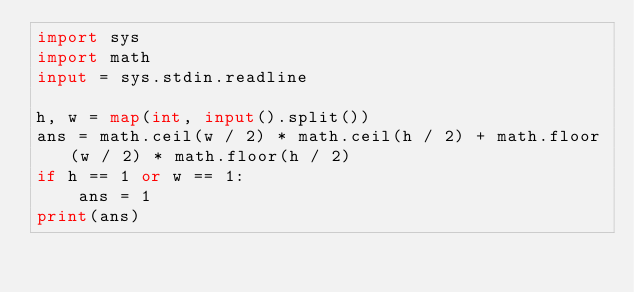Convert code to text. <code><loc_0><loc_0><loc_500><loc_500><_Python_>import sys
import math
input = sys.stdin.readline

h, w = map(int, input().split())
ans = math.ceil(w / 2) * math.ceil(h / 2) + math.floor(w / 2) * math.floor(h / 2)
if h == 1 or w == 1:
    ans = 1
print(ans)
</code> 